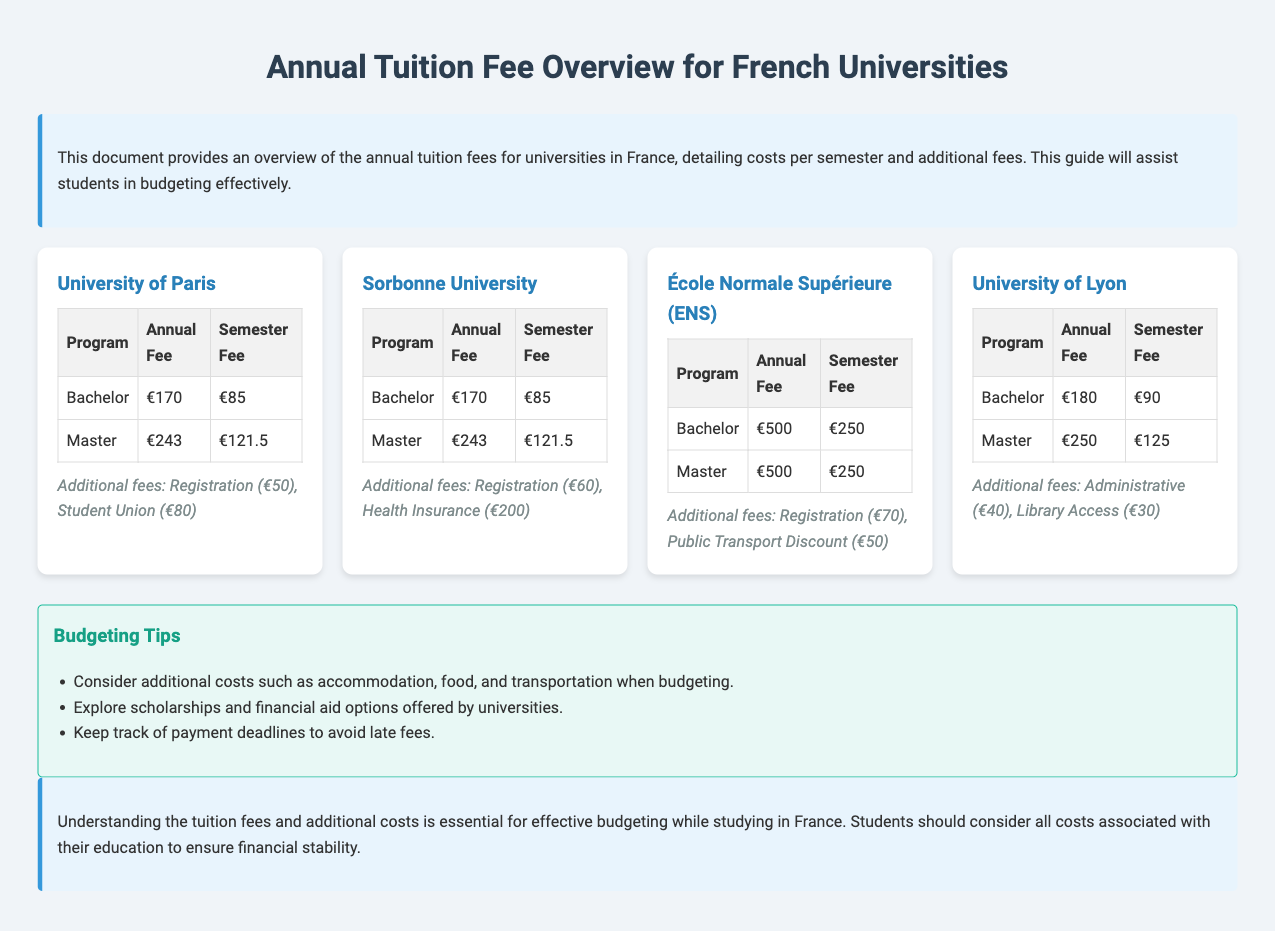What is the annual fee for a Bachelor's program at the University of Paris? The annual fee for a Bachelor's program at the University of Paris is directly listed in the table.
Answer: €170 What additional fee is charged by Sorbonne University for Health Insurance? The additional fee for Health Insurance is mentioned under the additional fees section for Sorbonne University.
Answer: €200 What is the semester fee for a Master's program at École Normale Supérieure? The semester fee for a Master's program can be found in the fee table for École Normale Supérieure.
Answer: €250 How much do students need to budget for Administrative fees at the University of Lyon? The Administrative fee is one of the additional fees listed for the University of Lyon.
Answer: €40 Which university has the highest annual fee for both Bachelor's and Master's programs? To answer this, we compare the annual fees for each program across the universities listed in the document.
Answer: École Normale Supérieure (ENS) What is a budgeting tip mentioned in the document? The document includes several tips, one of which is directly cited.
Answer: Explore scholarships and financial aid options offered by universities What is the total registration fee for all listed universities? The total registration fee can be calculated by summing the individual registration fees mentioned in the additional fees section across all universities.
Answer: €250 Which university has the lowest annual fee for a Bachelor's program? The document lists the annual fees for each university, making it easy to identify which has the lowest.
Answer: University of Paris and Sorbonne University 